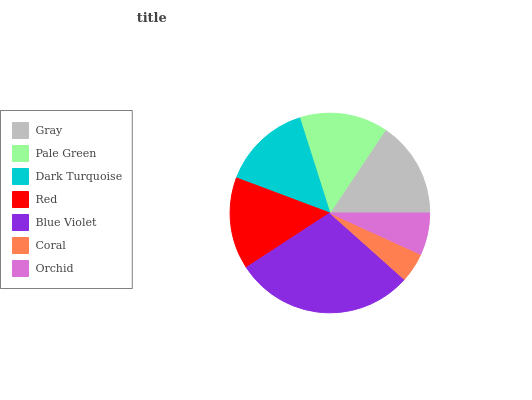Is Coral the minimum?
Answer yes or no. Yes. Is Blue Violet the maximum?
Answer yes or no. Yes. Is Pale Green the minimum?
Answer yes or no. No. Is Pale Green the maximum?
Answer yes or no. No. Is Gray greater than Pale Green?
Answer yes or no. Yes. Is Pale Green less than Gray?
Answer yes or no. Yes. Is Pale Green greater than Gray?
Answer yes or no. No. Is Gray less than Pale Green?
Answer yes or no. No. Is Dark Turquoise the high median?
Answer yes or no. Yes. Is Dark Turquoise the low median?
Answer yes or no. Yes. Is Red the high median?
Answer yes or no. No. Is Pale Green the low median?
Answer yes or no. No. 